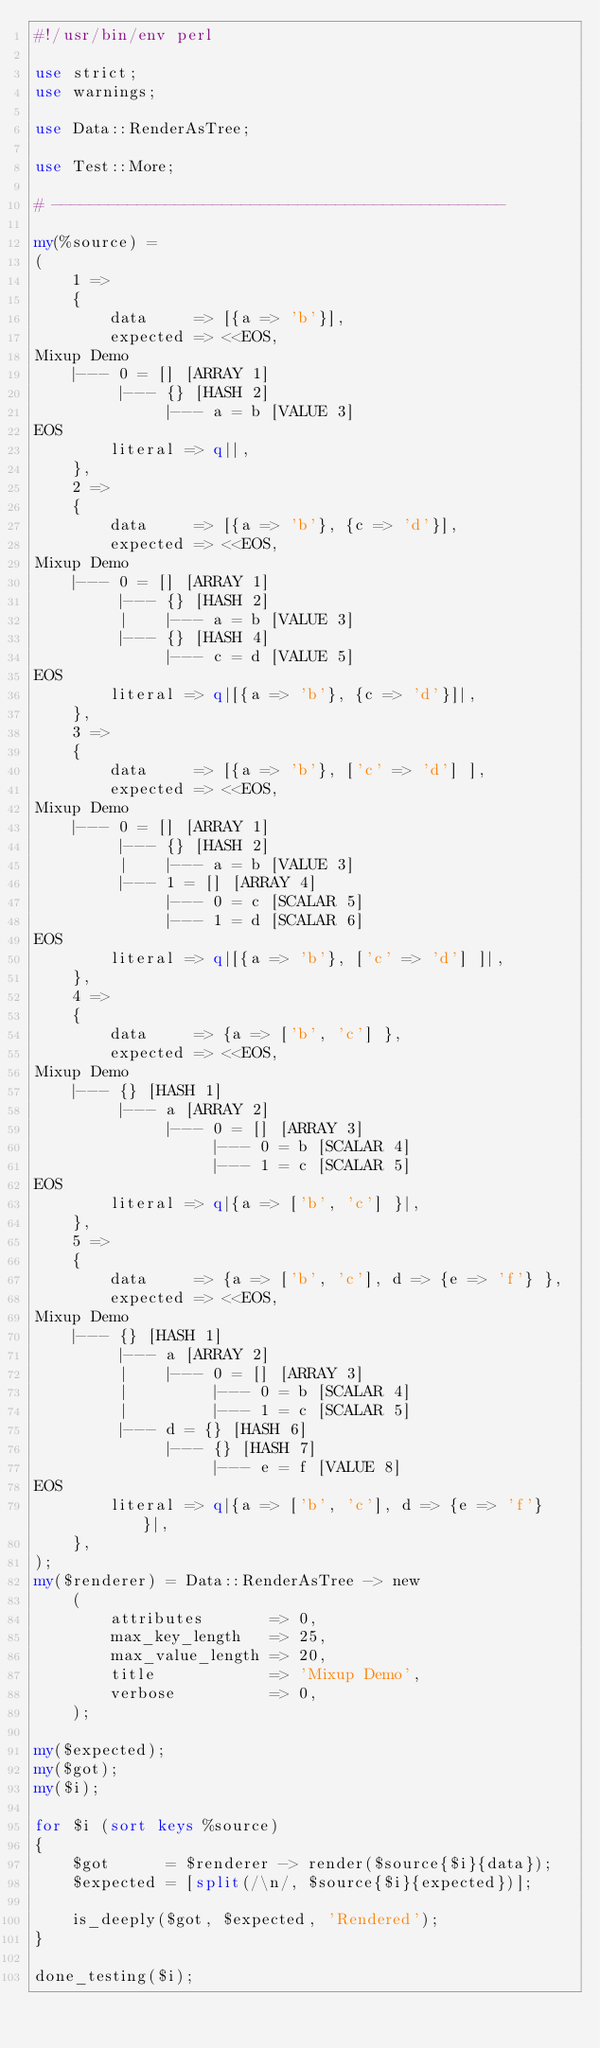Convert code to text. <code><loc_0><loc_0><loc_500><loc_500><_Perl_>#!/usr/bin/env perl

use strict;
use warnings;

use Data::RenderAsTree;

use Test::More;

# ------------------------------------------------

my(%source) =
(
	1 =>
	{
		data     => [{a => 'b'}],
		expected => <<EOS,
Mixup Demo
    |--- 0 = [] [ARRAY 1]
         |--- {} [HASH 2]
              |--- a = b [VALUE 3]
EOS
		literal => q||,
	},
	2 =>
	{
		data     => [{a => 'b'}, {c => 'd'}],
		expected => <<EOS,
Mixup Demo
    |--- 0 = [] [ARRAY 1]
         |--- {} [HASH 2]
         |    |--- a = b [VALUE 3]
         |--- {} [HASH 4]
              |--- c = d [VALUE 5]
EOS
		literal => q|[{a => 'b'}, {c => 'd'}]|,
	},
	3 =>
	{
		data     => [{a => 'b'}, ['c' => 'd'] ],
		expected => <<EOS,
Mixup Demo
    |--- 0 = [] [ARRAY 1]
         |--- {} [HASH 2]
         |    |--- a = b [VALUE 3]
         |--- 1 = [] [ARRAY 4]
              |--- 0 = c [SCALAR 5]
              |--- 1 = d [SCALAR 6]
EOS
		literal => q|[{a => 'b'}, ['c' => 'd'] ]|,
	},
	4 =>
	{
		data     => {a => ['b', 'c'] },
		expected => <<EOS,
Mixup Demo
    |--- {} [HASH 1]
         |--- a [ARRAY 2]
              |--- 0 = [] [ARRAY 3]
                   |--- 0 = b [SCALAR 4]
                   |--- 1 = c [SCALAR 5]
EOS
		literal => q|{a => ['b', 'c'] }|,
	},
	5 =>
	{
		data     => {a => ['b', 'c'], d => {e => 'f'} },
		expected => <<EOS,
Mixup Demo
    |--- {} [HASH 1]
         |--- a [ARRAY 2]
         |    |--- 0 = [] [ARRAY 3]
         |         |--- 0 = b [SCALAR 4]
         |         |--- 1 = c [SCALAR 5]
         |--- d = {} [HASH 6]
              |--- {} [HASH 7]
                   |--- e = f [VALUE 8]
EOS
		literal => q|{a => ['b', 'c'], d => {e => 'f'} }|,
	},
);
my($renderer) = Data::RenderAsTree -> new
	(
		attributes       => 0,
		max_key_length   => 25,
		max_value_length => 20,
		title            => 'Mixup Demo',
		verbose          => 0,
	);

my($expected);
my($got);
my($i);

for $i (sort keys %source)
{
	$got      = $renderer -> render($source{$i}{data});
	$expected = [split(/\n/, $source{$i}{expected})];

	is_deeply($got, $expected, 'Rendered');
}

done_testing($i);
</code> 